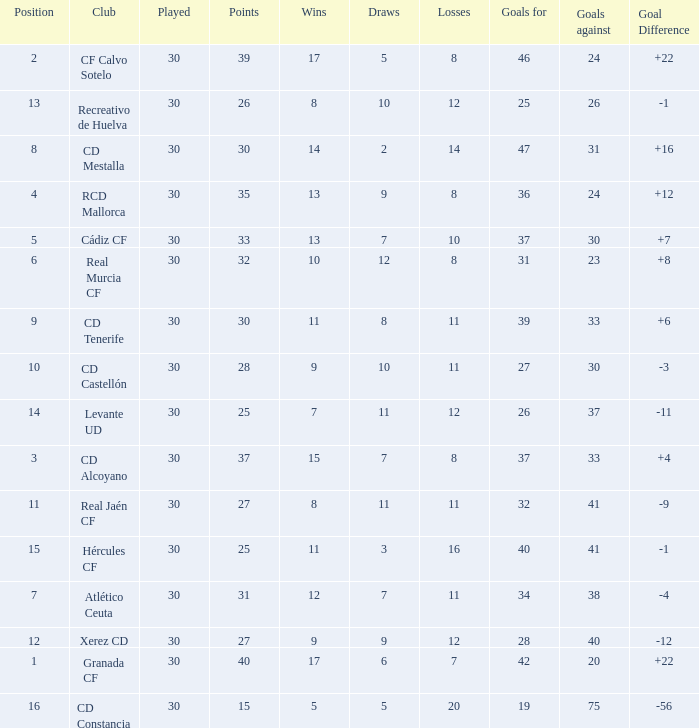How many Wins have Goals against smaller than 30, and Goals for larger than 25, and Draws larger than 5? 3.0. Parse the table in full. {'header': ['Position', 'Club', 'Played', 'Points', 'Wins', 'Draws', 'Losses', 'Goals for', 'Goals against', 'Goal Difference'], 'rows': [['2', 'CF Calvo Sotelo', '30', '39', '17', '5', '8', '46', '24', '+22'], ['13', 'Recreativo de Huelva', '30', '26', '8', '10', '12', '25', '26', '-1'], ['8', 'CD Mestalla', '30', '30', '14', '2', '14', '47', '31', '+16'], ['4', 'RCD Mallorca', '30', '35', '13', '9', '8', '36', '24', '+12'], ['5', 'Cádiz CF', '30', '33', '13', '7', '10', '37', '30', '+7'], ['6', 'Real Murcia CF', '30', '32', '10', '12', '8', '31', '23', '+8'], ['9', 'CD Tenerife', '30', '30', '11', '8', '11', '39', '33', '+6'], ['10', 'CD Castellón', '30', '28', '9', '10', '11', '27', '30', '-3'], ['14', 'Levante UD', '30', '25', '7', '11', '12', '26', '37', '-11'], ['3', 'CD Alcoyano', '30', '37', '15', '7', '8', '37', '33', '+4'], ['11', 'Real Jaén CF', '30', '27', '8', '11', '11', '32', '41', '-9'], ['15', 'Hércules CF', '30', '25', '11', '3', '16', '40', '41', '-1'], ['7', 'Atlético Ceuta', '30', '31', '12', '7', '11', '34', '38', '-4'], ['12', 'Xerez CD', '30', '27', '9', '9', '12', '28', '40', '-12'], ['1', 'Granada CF', '30', '40', '17', '6', '7', '42', '20', '+22'], ['16', 'CD Constancia', '30', '15', '5', '5', '20', '19', '75', '-56']]} 